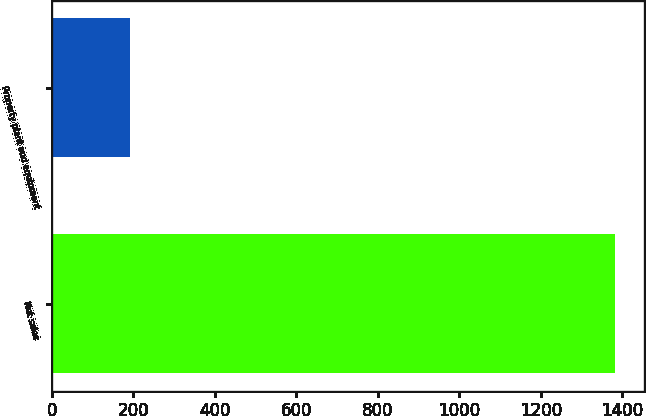Convert chart to OTSL. <chart><loc_0><loc_0><loc_500><loc_500><bar_chart><fcel>Net sales<fcel>Property plant and equipment<nl><fcel>1383<fcel>192.5<nl></chart> 